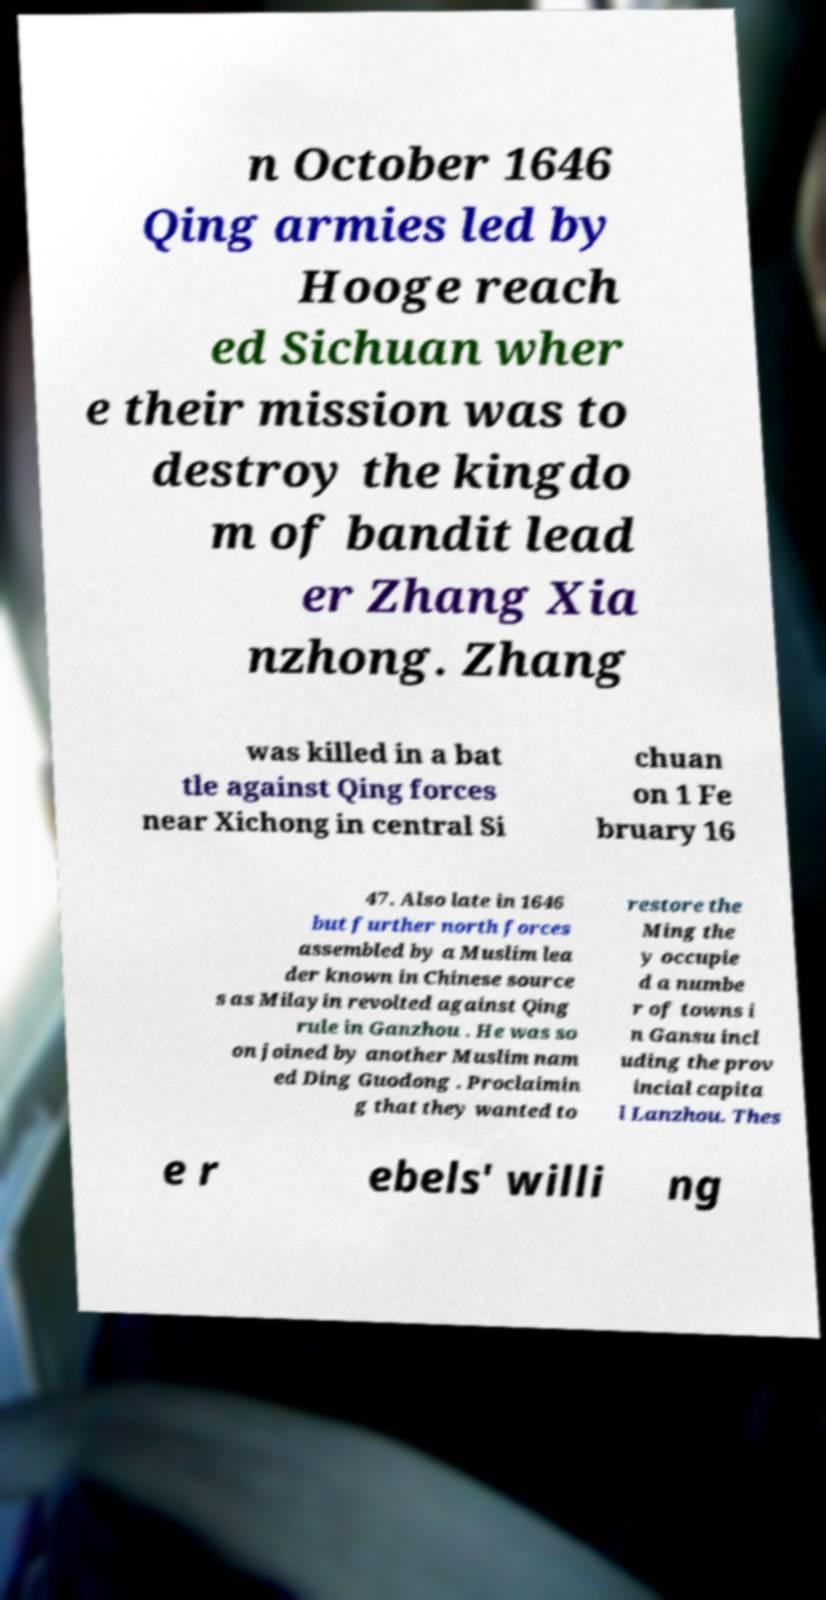Could you assist in decoding the text presented in this image and type it out clearly? n October 1646 Qing armies led by Hooge reach ed Sichuan wher e their mission was to destroy the kingdo m of bandit lead er Zhang Xia nzhong. Zhang was killed in a bat tle against Qing forces near Xichong in central Si chuan on 1 Fe bruary 16 47. Also late in 1646 but further north forces assembled by a Muslim lea der known in Chinese source s as Milayin revolted against Qing rule in Ganzhou . He was so on joined by another Muslim nam ed Ding Guodong . Proclaimin g that they wanted to restore the Ming the y occupie d a numbe r of towns i n Gansu incl uding the prov incial capita l Lanzhou. Thes e r ebels' willi ng 